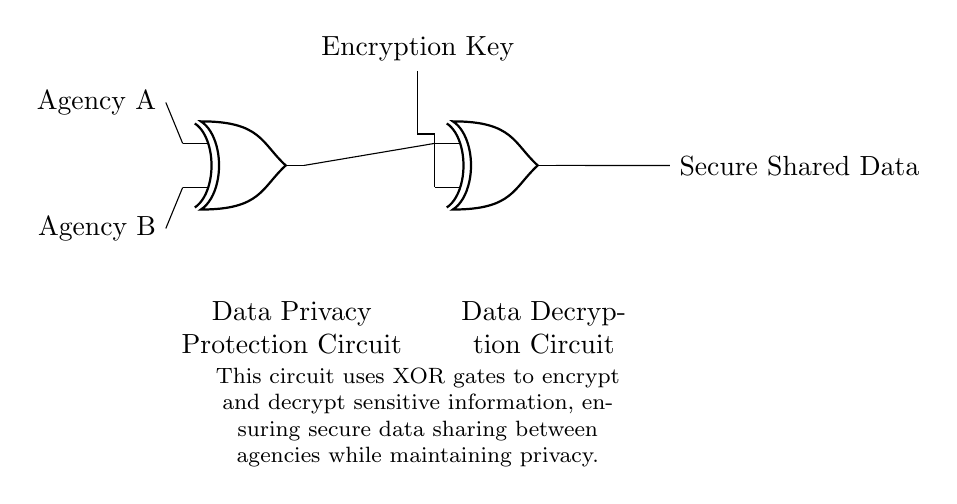What are the two input agencies in the circuit? The circuit identifies Agency A and Agency B as the two input agencies. They are marked at the left side of the diagram.
Answer: Agency A, Agency B How many XOR gates are used in this circuit? The circuit has two XOR gates, one for encrypting and the other for decrypting the data, which can be observed positioned in the center and right of the diagram.
Answer: Two What is the output of the circuit? The output of the circuit is labeled as Secure Shared Data and can be seen on the right side where the final output is indicated.
Answer: Secure Shared Data What is the purpose of the Encryption Key in the circuit? The Encryption Key is used as a second input to one of the XOR gates, facilitating the data encryption process to ensure privacy in data sharing.
Answer: Data encryption How does the circuit ensure privacy during information sharing? The circuit uses XOR gates, which perform bitwise exclusive OR operations, enabling the encryption and decryption of data by combining it with an encryption key, maintaining the privacy of the information shared between agencies.
Answer: XOR gates 